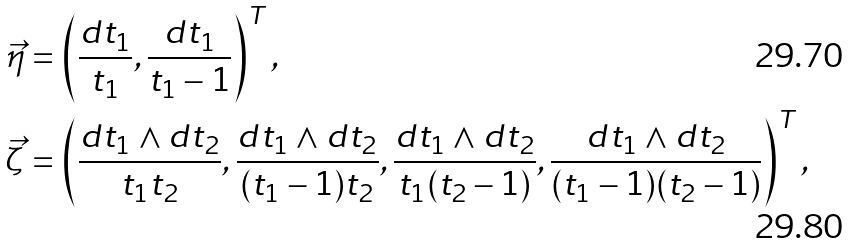Convert formula to latex. <formula><loc_0><loc_0><loc_500><loc_500>\vec { \eta } & = \left ( \frac { d t _ { 1 } } { t _ { 1 } } , \frac { d t _ { 1 } } { t _ { 1 } - 1 } \right ) ^ { T } , \\ \vec { \zeta } & = \left ( \frac { d t _ { 1 } \wedge d t _ { 2 } } { t _ { 1 } t _ { 2 } } , \frac { d t _ { 1 } \wedge d t _ { 2 } } { ( t _ { 1 } - 1 ) t _ { 2 } } , \frac { d t _ { 1 } \wedge d t _ { 2 } } { t _ { 1 } ( t _ { 2 } - 1 ) } , \frac { d t _ { 1 } \wedge d t _ { 2 } } { ( t _ { 1 } - 1 ) ( t _ { 2 } - 1 ) } \right ) ^ { T } ,</formula> 